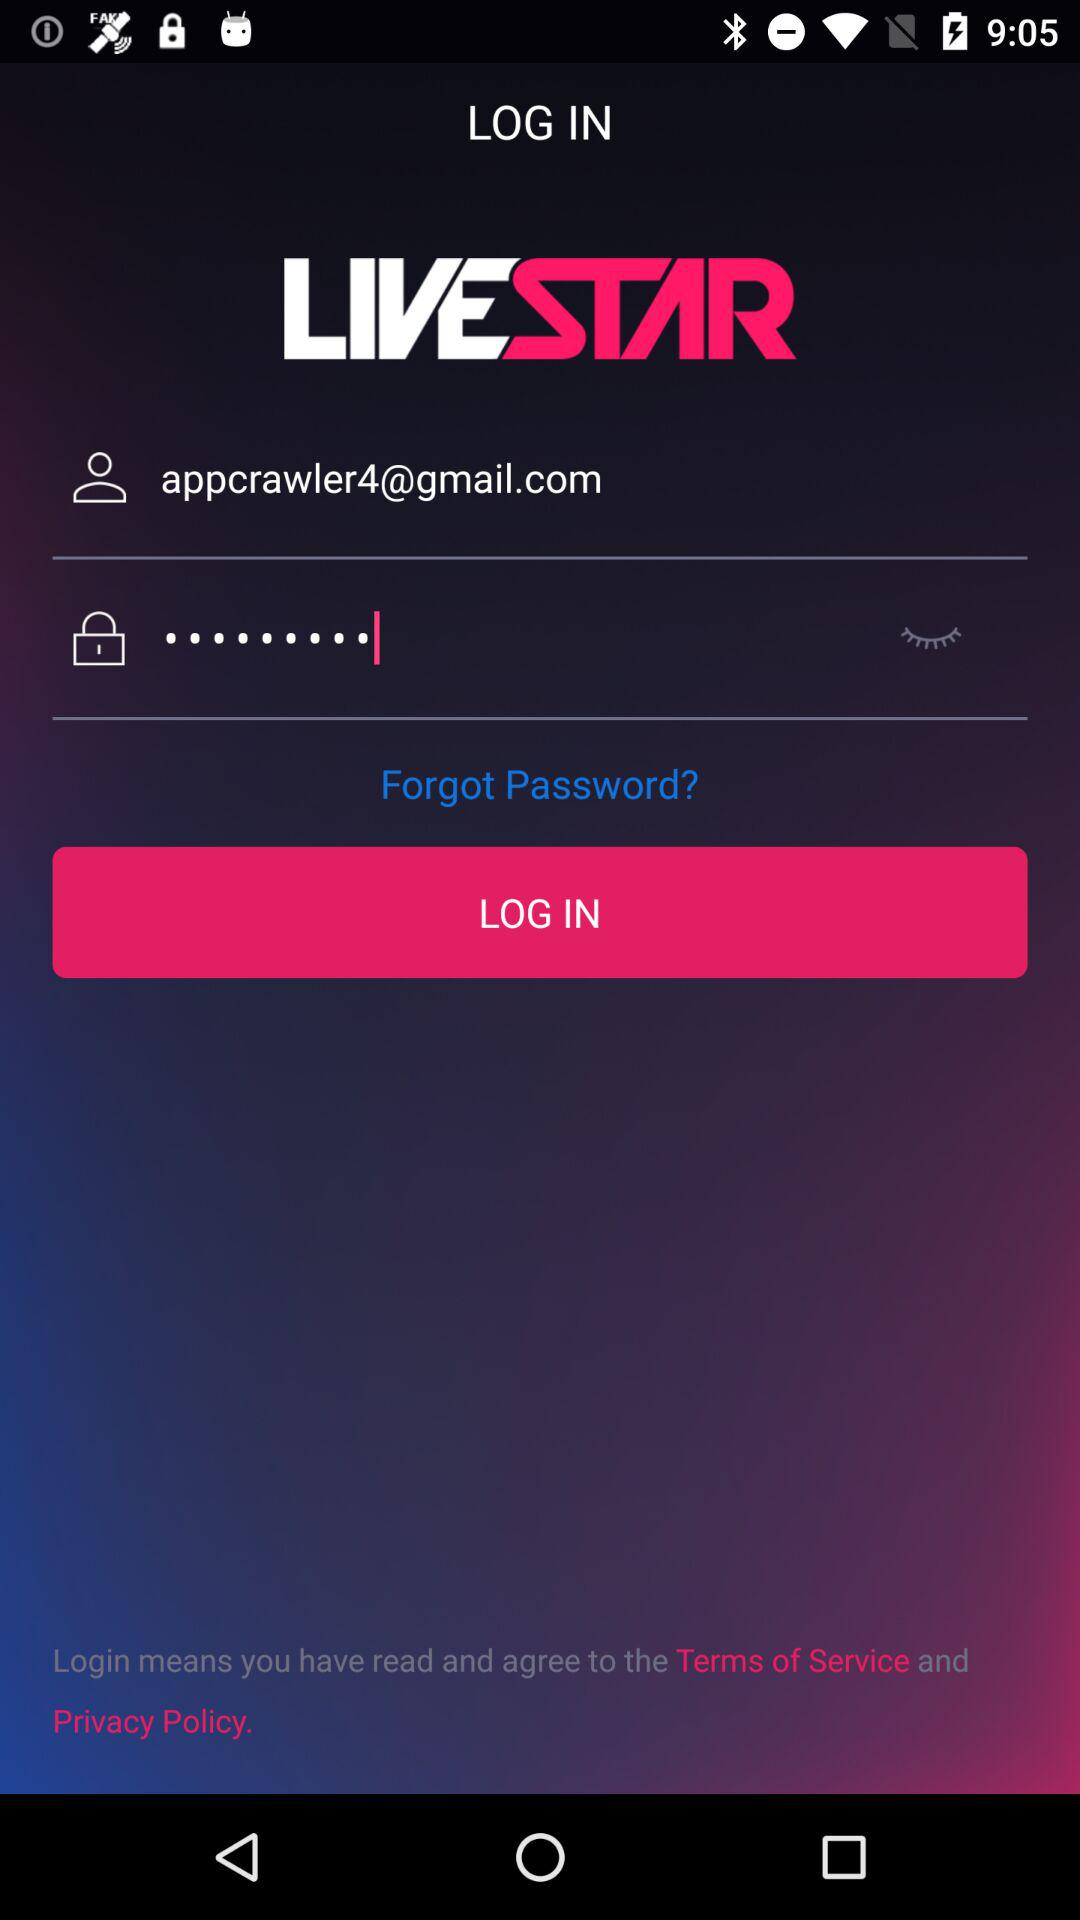How many items are required for login?
Answer the question using a single word or phrase. 2 